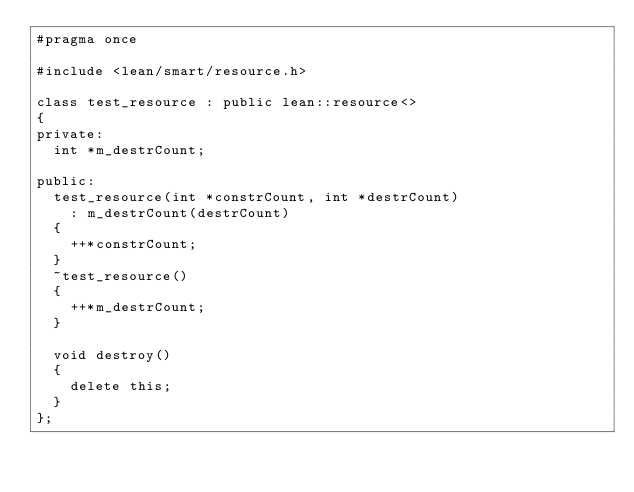<code> <loc_0><loc_0><loc_500><loc_500><_C_>#pragma once

#include <lean/smart/resource.h>

class test_resource : public lean::resource<>
{
private:
	int *m_destrCount;

public:
	test_resource(int *constrCount, int *destrCount)
		: m_destrCount(destrCount)
	{
		++*constrCount;
	}
	~test_resource()
	{
		++*m_destrCount;
	}

	void destroy()
	{
		delete this;
	}
};
</code> 